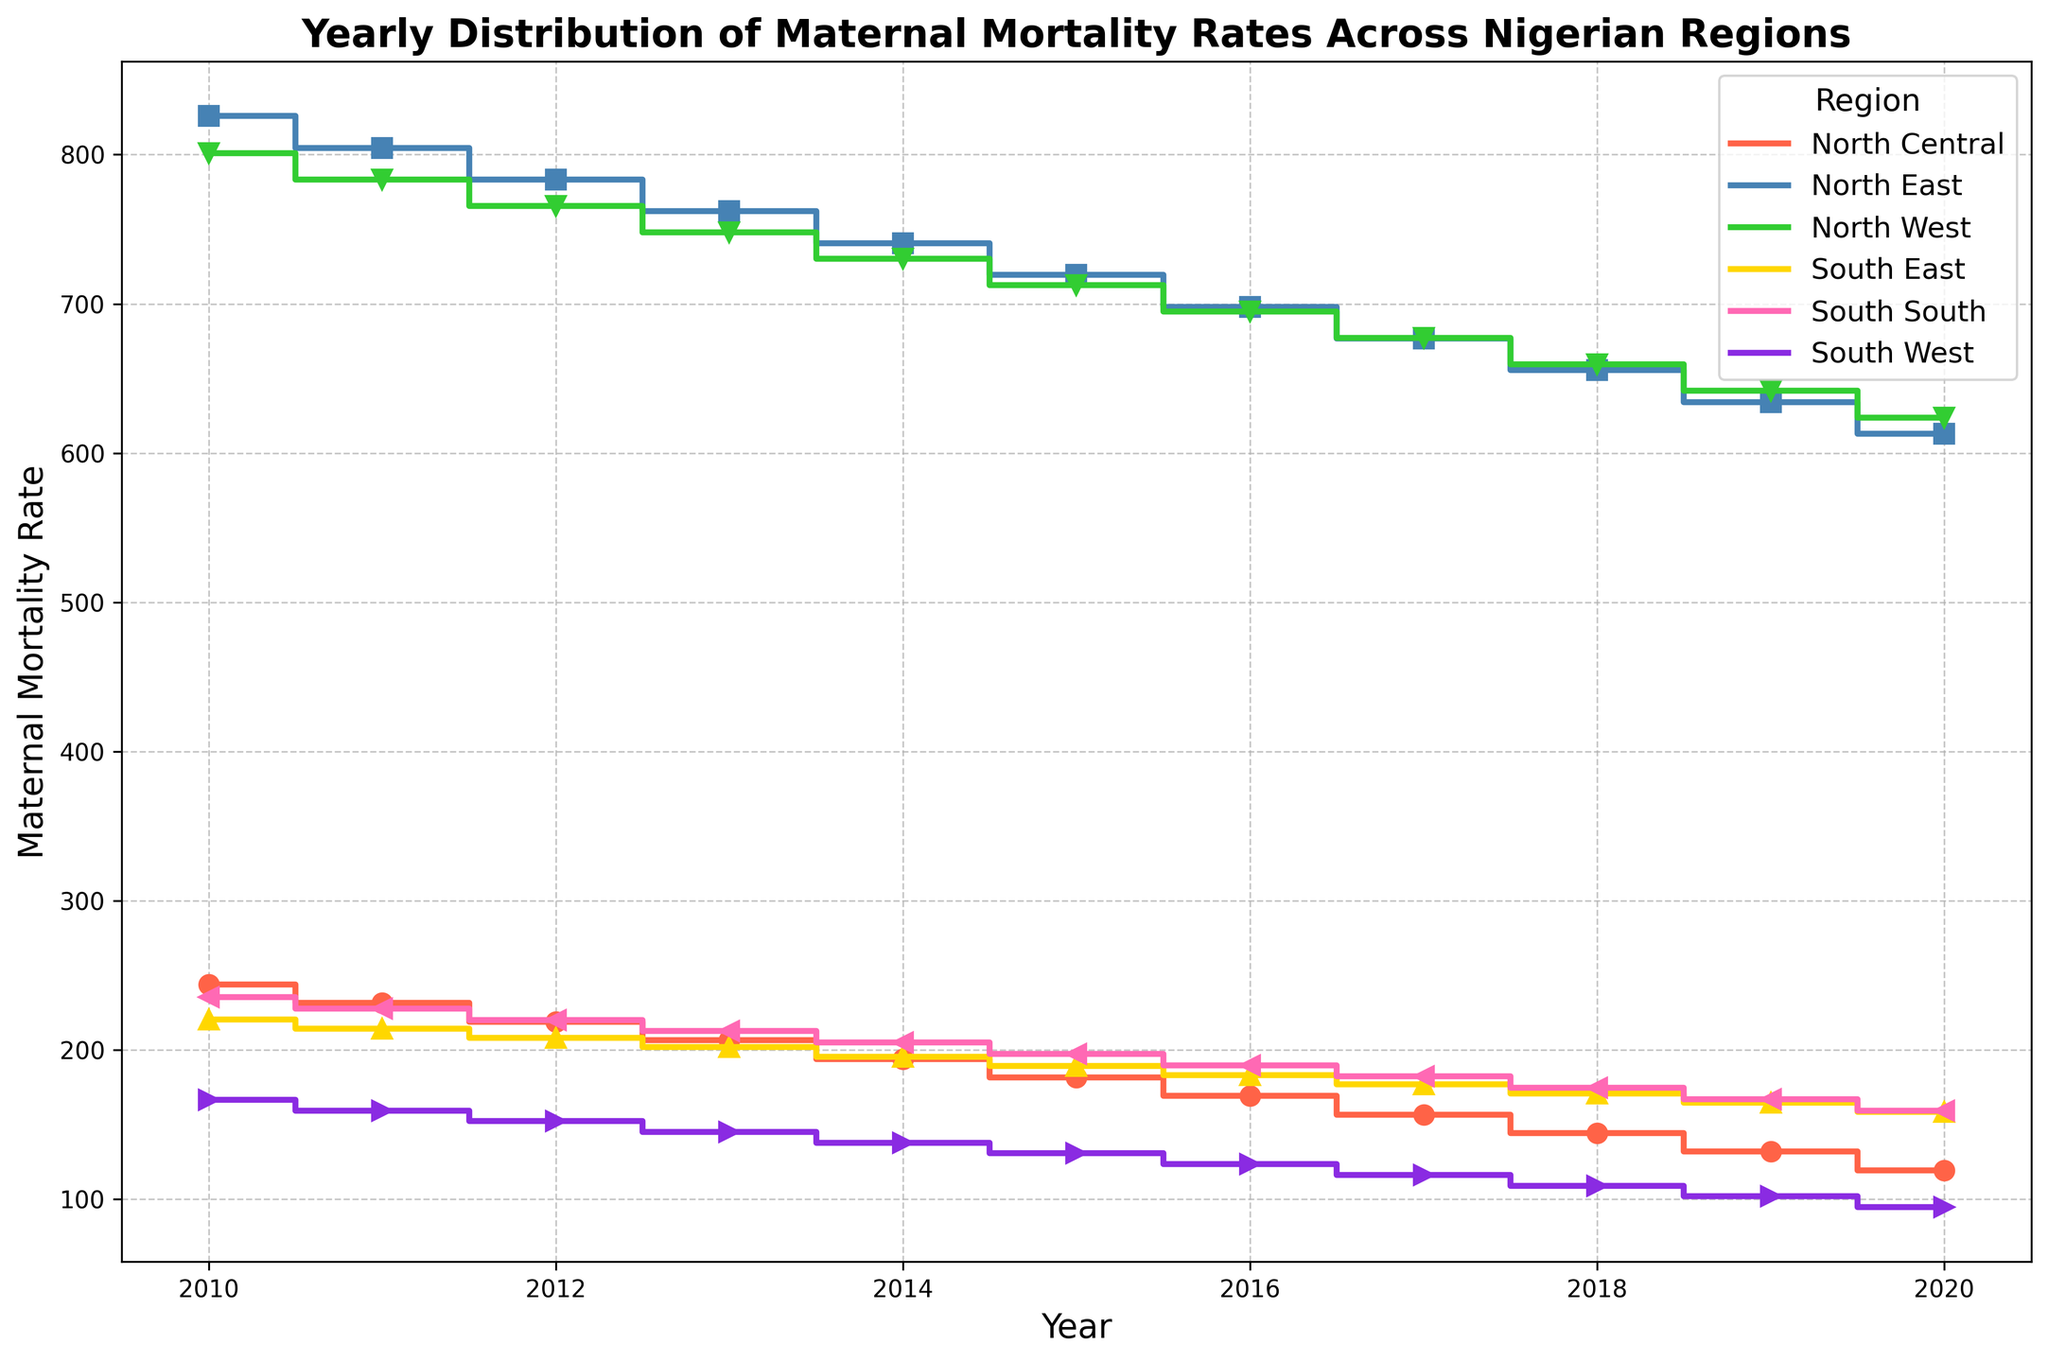What is the trend in maternal mortality rates in the North East region from 2010 to 2020? The trend in the North East region can be observed by noting the heights of the steps on the plot for the North East over the years 2010 to 2020. The steps show a downward trend, indicating a decrease in maternal mortality rates over this period.
Answer: Decreasing Which region had the lowest maternal mortality rate in 2020? To find the region with the lowest maternal mortality rate in 2020, look at the endpoints of the steps for each region in 2020. The lowest endpoint is for the South West region.
Answer: South West By how much did the maternal mortality rate decrease in the North West region between 2010 and 2020? To determine the decrease, subtract the maternal mortality rate in the North West for 2020 from the rate in 2010. The rates are 800.8 in 2010 and 623.9 in 2020. 800.8 - 623.9 = 176.9
Answer: 176.9 Which regions show consistently lower maternal mortality rates compared to the North West throughout the years? Compare the step heights of all other regions to the North West for all years. South East, South South, and South West consistently have lower heights than the North West.
Answer: South East, South South, South West In which year did North Central have a maternal mortality rate closest to 200? Examine the step heights for North Central and identify the year closest to 200. The rate for North Central is closest to 200 in 2014 at 194.1.
Answer: 2014 What is the difference in maternal mortality rates between North East and South East in 2017? Look at the step heights for both North East and South East in 2017. The rates are 676.8 for North East and 177.0 for South East. The difference is 676.8 - 177.0 = 499.8
Answer: 499.8 Which region shows the most significant decrease in maternal mortality rates from 2010 to 2020? Calculate the difference in maternal mortality rates between 2010 and 2020 for all regions. South West shows the largest decrease from 166.6 in 2010 to 94.7 in 2020, a decrease of 71.9.
Answer: South West What is the average maternal mortality rate for the South South region over the entire period? To calculate the average, sum the rates for South South over the years 2010 to 2020 and then divide by the number of years (11). The sum is 235.4 + 227.8 + 220.2 + 212.6 + 205.0 + 197.4 + 189.8 + 182.2 + 174.6 + 167.0 + 159.4 = 2071.4. The average is 2071.4 / 11 = 188.31
Answer: 188.31 